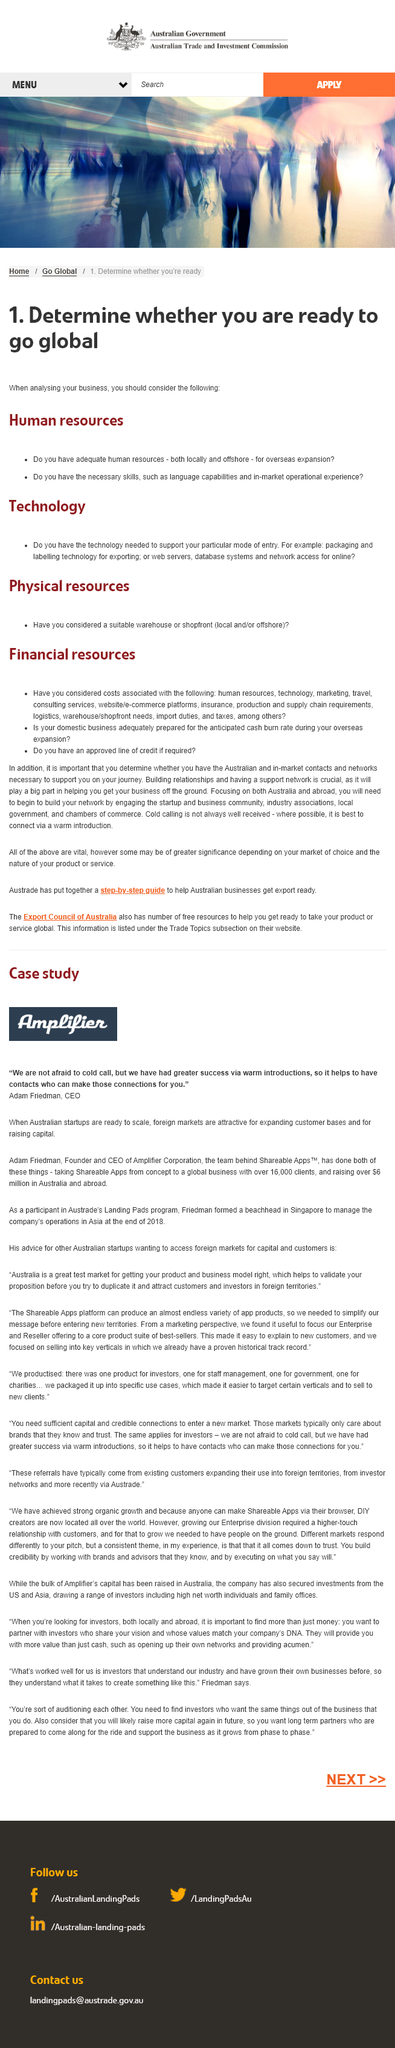Indicate a few pertinent items in this graphic. When determining if your business is ready to go global, it is essential to consider the categories of human resources, technology, and physical resources. These three categories will help assess your business's readiness to expand internationally and identify any areas that may require additional attention or investment. When determining if a business is ready to go global, it is crucial to consider the technology implications and whether the business has the necessary technology to support the chosen mode of entry. For example, if the business is planning to export, packaging and labeling technology must be considered to ensure compliance with international regulations. It is necessary to evaluate the availability of appropriate warehouses or retail spaces, as well as local or remote locations, in order to determine if a business is prepared to expand globally. 